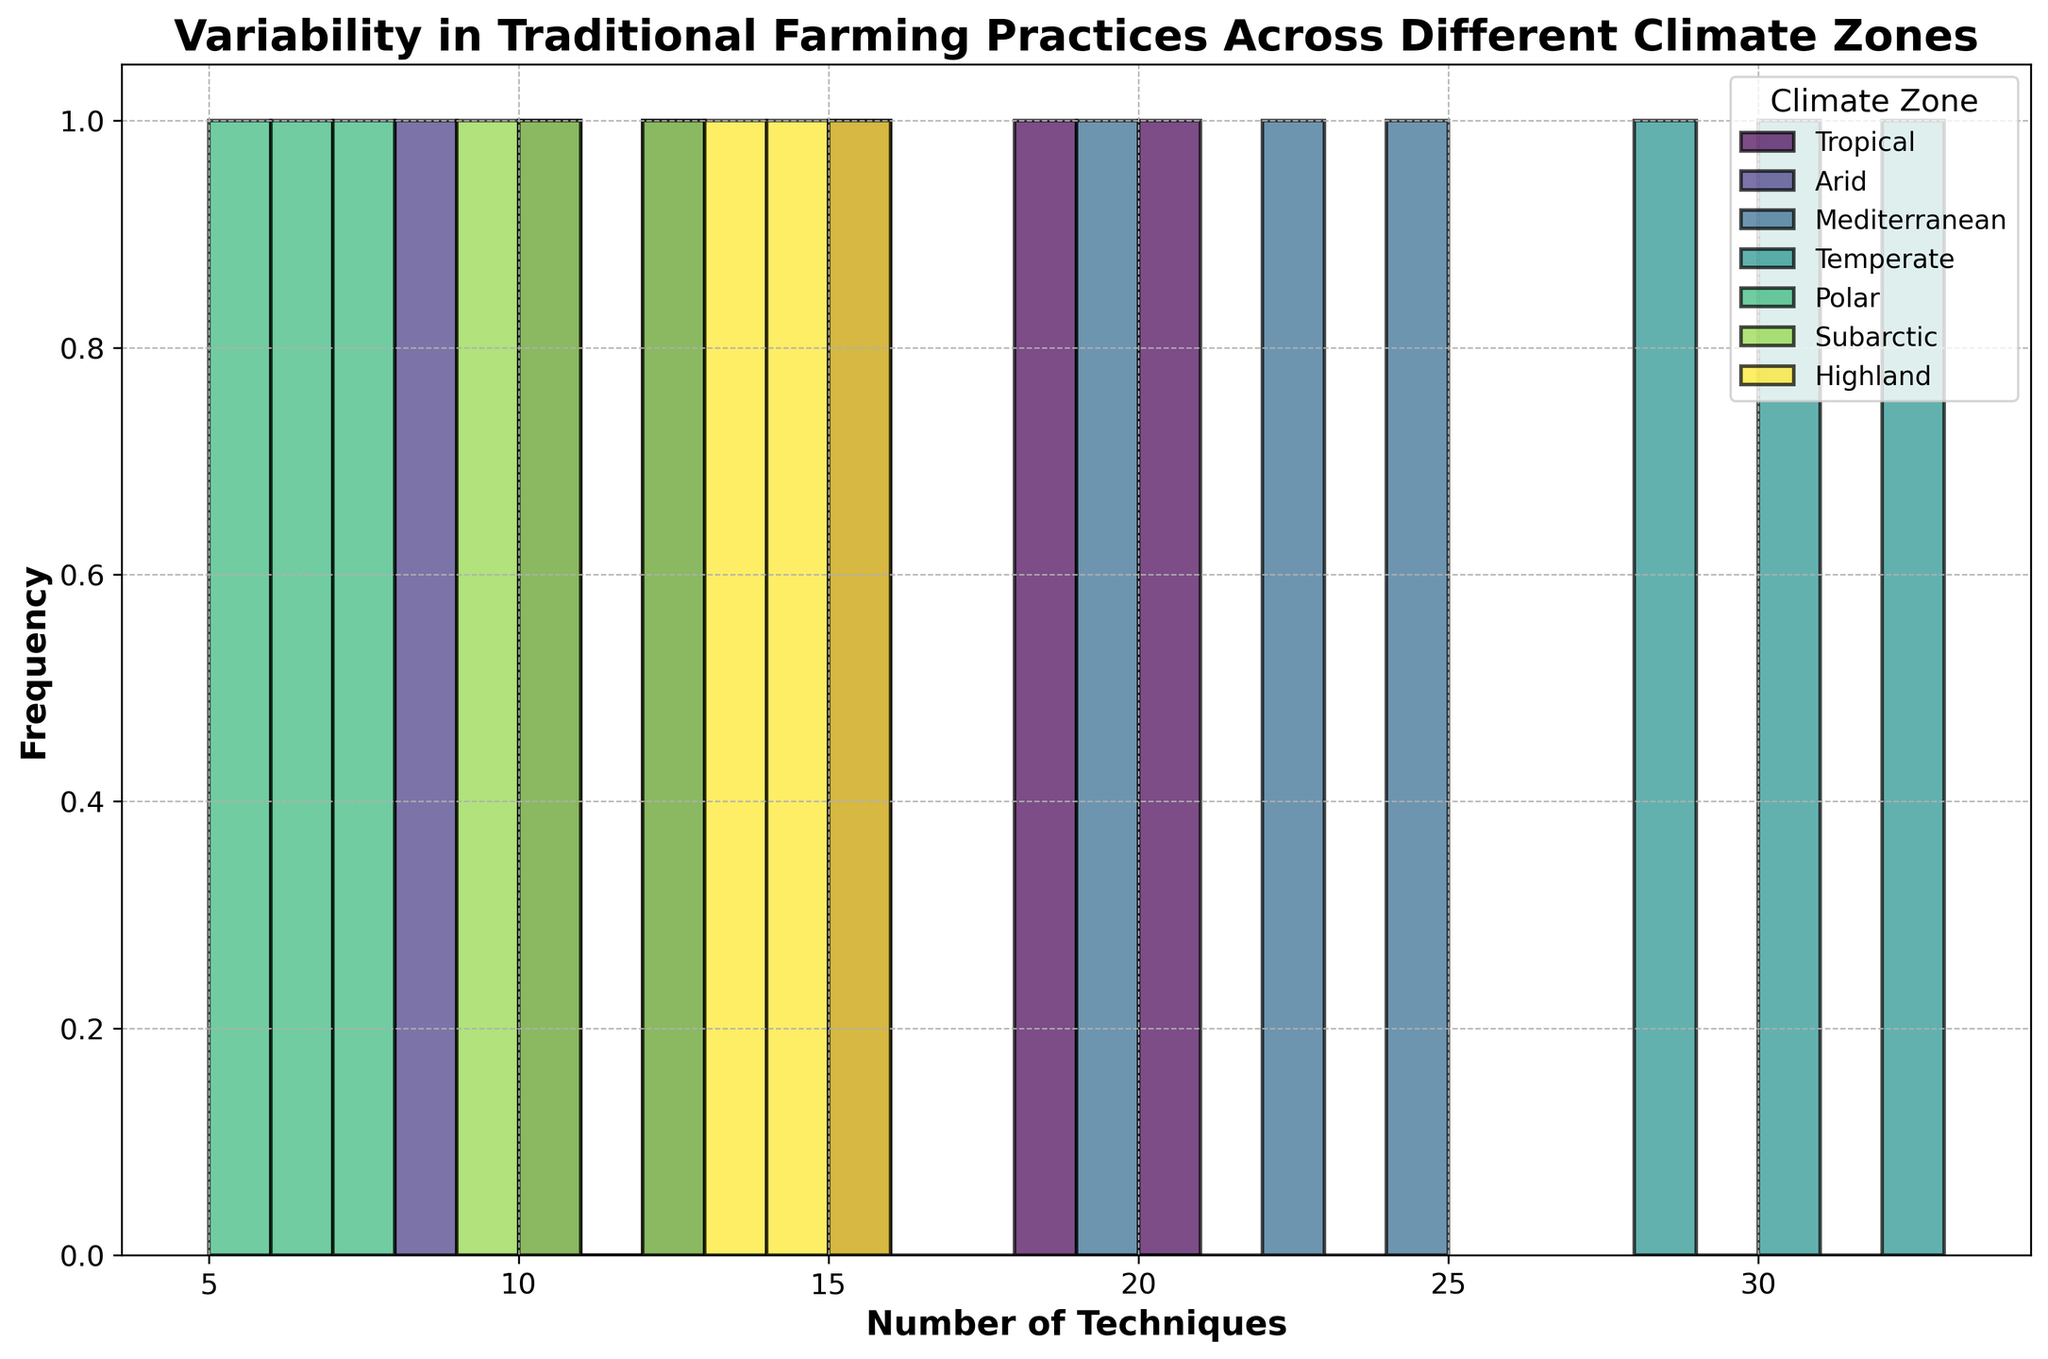Which climate zone has the highest frequency of farming techniques with 10 occurrences? By examining the histogram, find the climate zone with the highest bar at the 10 technique mark.
Answer: Arid What is the median number of techniques in the Mediterranean zone? To find the median, sort the Mediterranean values (19, 22, 24) and select the middle one.
Answer: 22 Which climate zone has farming practices with the smallest variability in frequency? The variability can be observed by the spread and height of the bars. The least spread and uniform height indicate low variability.
Answer: Polar Which climate zone has more than one peak in the distribution of its farming techniques? Look for climate zones with multiple bars of considerable height, indicating several peaks.
Answer: Tropical How does the frequency of techniques in the Arid zone compare to the Polar zone for the lowest value? Compare the heights of the bars corresponding to the lowest value (5 for Polar and 8 for Arid).
Answer: Arid has more What's the interquartile range (IQR) of techniques in the Temperate zone? Find the 25th percentile (Q1): 28 and 75th percentile (Q3): 32 values, then IQR = Q3 - Q1.
Answer: 4 How does the range of techniques in the Highland zone compare with the Subarctic zone? Determine the range by finding the difference between max and min values for each: (15−13) and (12−9).
Answer: Highland has a smaller range Which climate zone uses the most varied number of techniques? Identify the climate zone by the width and spread of the bars; the highest range indicates the most varied.
Answer: Temperate What is the modal number of techniques in the Tropical zone? Find the number of techniques that occurs most frequently in Tropical values (15, 20, 18).
Answer: 15 How do the technique frequencies between Temperate and Mediterranean zones differ for the highest value? Compare the heights of the bars at the highest technique values (32 for Temperate and 24 for Mediterranean).
Answer: Temperate has higher 